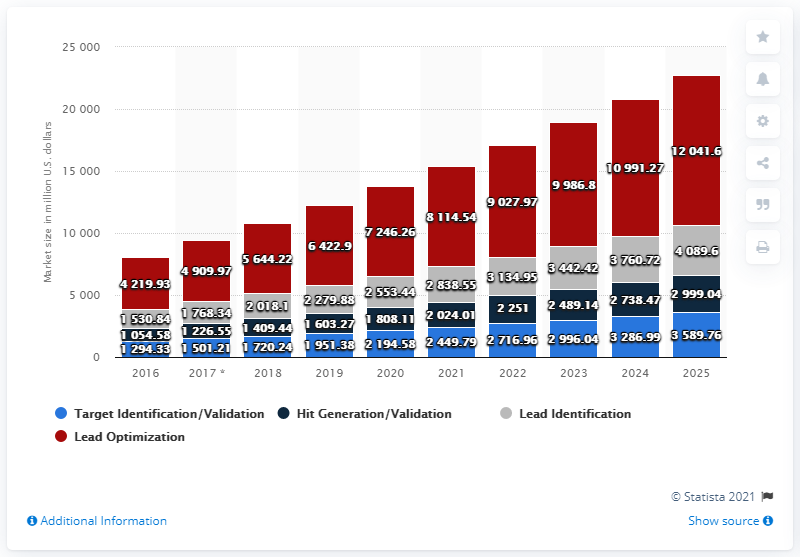List a handful of essential elements in this visual. In 2016, the value of lead optimization was 4219.93. The global market for biologics drug discovery in 2016 was 81,14.54. 